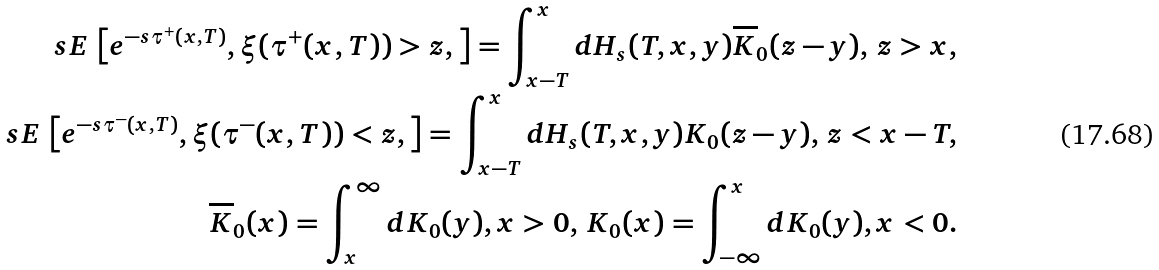<formula> <loc_0><loc_0><loc_500><loc_500>s E \, \left [ e ^ { - s \tau ^ { + } ( x , T ) } , \xi ( \tau ^ { + } ( x , T ) ) > z , \right ] = \int _ { x - T } ^ { x } d H _ { s } ( T , x , y ) \overline { K } _ { 0 } ( z - y ) , \, z > x , \\ s E \, \left [ e ^ { - s \tau ^ { - } ( x , T ) } , \xi ( \tau ^ { - } ( x , T ) ) < z , \right ] = \int _ { x - T } ^ { x } d H _ { s } ( T , x , y ) K _ { 0 } ( z - y ) , \, z < x - T , \\ \overline { K } _ { 0 } ( x ) = \int _ { x } ^ { \infty } d K _ { 0 } ( y ) , x > 0 , \, K _ { 0 } ( x ) = \int _ { - \infty } ^ { x } d K _ { 0 } ( y ) , x < 0 .</formula> 